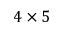<formula> <loc_0><loc_0><loc_500><loc_500>4 \times 5</formula> 